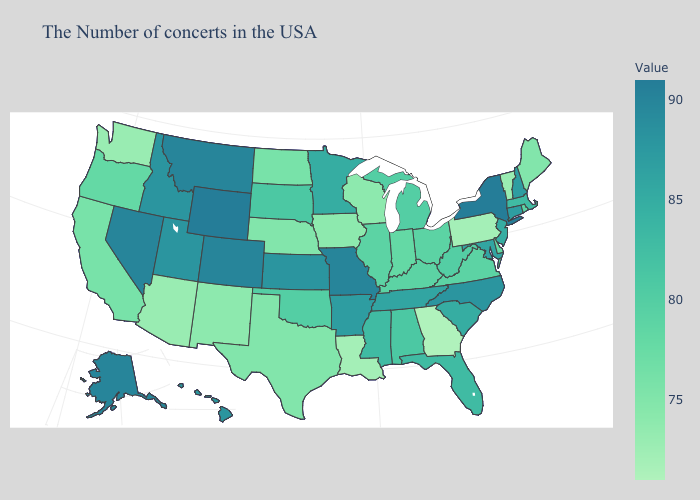Which states have the highest value in the USA?
Concise answer only. New York, Wyoming. Does Louisiana have the lowest value in the South?
Keep it brief. No. Does the map have missing data?
Concise answer only. No. Does Connecticut have a higher value than Alaska?
Short answer required. No. Among the states that border New Hampshire , does Vermont have the lowest value?
Quick response, please. Yes. Which states have the lowest value in the USA?
Concise answer only. Georgia. Does the map have missing data?
Short answer required. No. 